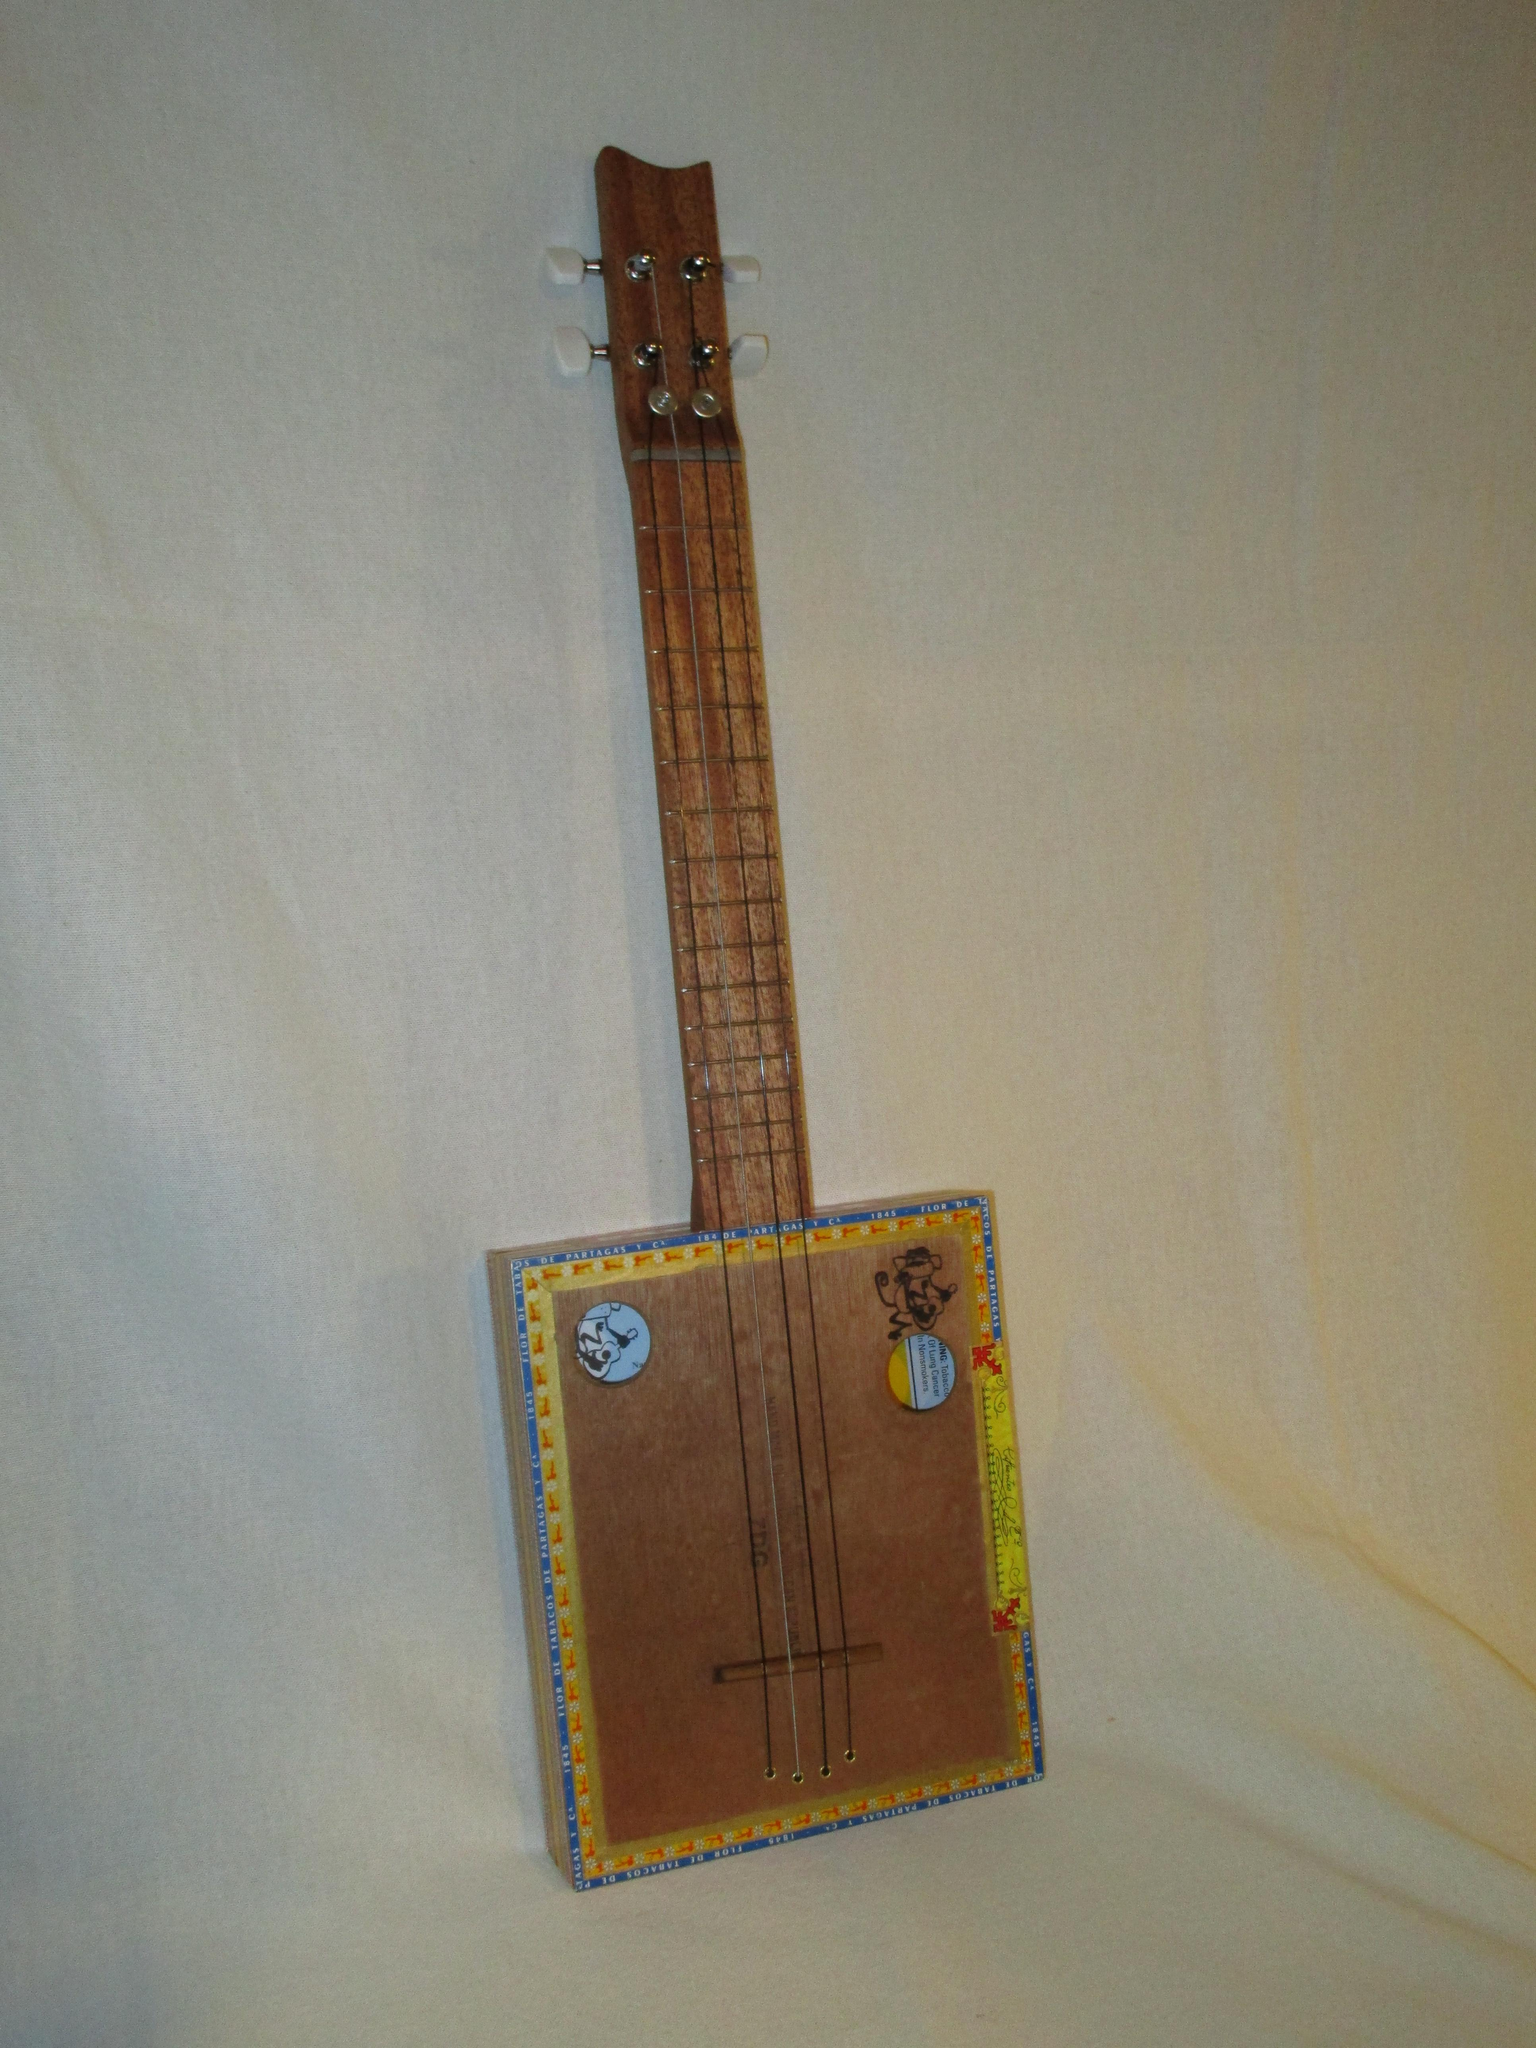What musical instrument is present in the image? There is a guitar in the image. What can be seen in the background of the image? There is a white curtain in the background of the image. What type of offer is being made by the owl in the image? There is no owl present in the image, so no offer can be attributed to an owl. 